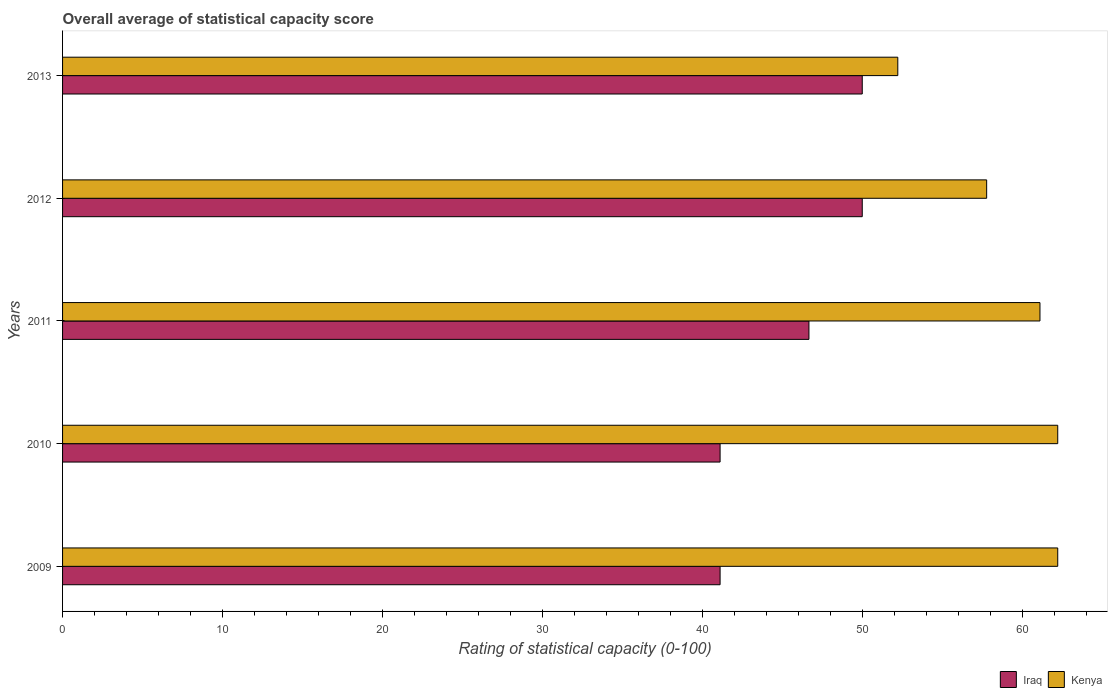How many different coloured bars are there?
Provide a succinct answer. 2. How many bars are there on the 3rd tick from the top?
Your answer should be very brief. 2. How many bars are there on the 5th tick from the bottom?
Provide a succinct answer. 2. What is the rating of statistical capacity in Kenya in 2012?
Offer a very short reply. 57.78. Across all years, what is the maximum rating of statistical capacity in Iraq?
Offer a terse response. 50. Across all years, what is the minimum rating of statistical capacity in Kenya?
Ensure brevity in your answer.  52.22. In which year was the rating of statistical capacity in Iraq maximum?
Provide a succinct answer. 2012. In which year was the rating of statistical capacity in Kenya minimum?
Ensure brevity in your answer.  2013. What is the total rating of statistical capacity in Iraq in the graph?
Provide a short and direct response. 228.89. What is the difference between the rating of statistical capacity in Kenya in 2009 and the rating of statistical capacity in Iraq in 2013?
Your response must be concise. 12.22. What is the average rating of statistical capacity in Iraq per year?
Give a very brief answer. 45.78. In the year 2011, what is the difference between the rating of statistical capacity in Kenya and rating of statistical capacity in Iraq?
Your answer should be compact. 14.44. What is the ratio of the rating of statistical capacity in Kenya in 2009 to that in 2013?
Keep it short and to the point. 1.19. Is the rating of statistical capacity in Iraq in 2012 less than that in 2013?
Ensure brevity in your answer.  No. Is the difference between the rating of statistical capacity in Kenya in 2010 and 2012 greater than the difference between the rating of statistical capacity in Iraq in 2010 and 2012?
Give a very brief answer. Yes. What is the difference between the highest and the lowest rating of statistical capacity in Kenya?
Your response must be concise. 10. What does the 2nd bar from the top in 2013 represents?
Provide a succinct answer. Iraq. What does the 1st bar from the bottom in 2009 represents?
Your answer should be compact. Iraq. Are all the bars in the graph horizontal?
Keep it short and to the point. Yes. What is the difference between two consecutive major ticks on the X-axis?
Make the answer very short. 10. Where does the legend appear in the graph?
Offer a terse response. Bottom right. How many legend labels are there?
Ensure brevity in your answer.  2. What is the title of the graph?
Make the answer very short. Overall average of statistical capacity score. Does "Jordan" appear as one of the legend labels in the graph?
Make the answer very short. No. What is the label or title of the X-axis?
Your answer should be very brief. Rating of statistical capacity (0-100). What is the label or title of the Y-axis?
Make the answer very short. Years. What is the Rating of statistical capacity (0-100) in Iraq in 2009?
Your answer should be compact. 41.11. What is the Rating of statistical capacity (0-100) of Kenya in 2009?
Ensure brevity in your answer.  62.22. What is the Rating of statistical capacity (0-100) in Iraq in 2010?
Offer a terse response. 41.11. What is the Rating of statistical capacity (0-100) of Kenya in 2010?
Your answer should be very brief. 62.22. What is the Rating of statistical capacity (0-100) of Iraq in 2011?
Provide a short and direct response. 46.67. What is the Rating of statistical capacity (0-100) in Kenya in 2011?
Make the answer very short. 61.11. What is the Rating of statistical capacity (0-100) of Iraq in 2012?
Give a very brief answer. 50. What is the Rating of statistical capacity (0-100) of Kenya in 2012?
Your answer should be compact. 57.78. What is the Rating of statistical capacity (0-100) in Iraq in 2013?
Your answer should be compact. 50. What is the Rating of statistical capacity (0-100) of Kenya in 2013?
Give a very brief answer. 52.22. Across all years, what is the maximum Rating of statistical capacity (0-100) in Kenya?
Ensure brevity in your answer.  62.22. Across all years, what is the minimum Rating of statistical capacity (0-100) of Iraq?
Make the answer very short. 41.11. Across all years, what is the minimum Rating of statistical capacity (0-100) in Kenya?
Your response must be concise. 52.22. What is the total Rating of statistical capacity (0-100) of Iraq in the graph?
Offer a terse response. 228.89. What is the total Rating of statistical capacity (0-100) in Kenya in the graph?
Keep it short and to the point. 295.56. What is the difference between the Rating of statistical capacity (0-100) in Iraq in 2009 and that in 2010?
Offer a terse response. 0. What is the difference between the Rating of statistical capacity (0-100) of Kenya in 2009 and that in 2010?
Provide a short and direct response. 0. What is the difference between the Rating of statistical capacity (0-100) in Iraq in 2009 and that in 2011?
Provide a succinct answer. -5.56. What is the difference between the Rating of statistical capacity (0-100) of Kenya in 2009 and that in 2011?
Offer a terse response. 1.11. What is the difference between the Rating of statistical capacity (0-100) of Iraq in 2009 and that in 2012?
Offer a terse response. -8.89. What is the difference between the Rating of statistical capacity (0-100) in Kenya in 2009 and that in 2012?
Keep it short and to the point. 4.44. What is the difference between the Rating of statistical capacity (0-100) in Iraq in 2009 and that in 2013?
Your answer should be compact. -8.89. What is the difference between the Rating of statistical capacity (0-100) of Kenya in 2009 and that in 2013?
Your answer should be very brief. 10. What is the difference between the Rating of statistical capacity (0-100) in Iraq in 2010 and that in 2011?
Keep it short and to the point. -5.56. What is the difference between the Rating of statistical capacity (0-100) of Iraq in 2010 and that in 2012?
Give a very brief answer. -8.89. What is the difference between the Rating of statistical capacity (0-100) in Kenya in 2010 and that in 2012?
Keep it short and to the point. 4.44. What is the difference between the Rating of statistical capacity (0-100) of Iraq in 2010 and that in 2013?
Your answer should be very brief. -8.89. What is the difference between the Rating of statistical capacity (0-100) in Iraq in 2011 and that in 2012?
Provide a short and direct response. -3.33. What is the difference between the Rating of statistical capacity (0-100) in Kenya in 2011 and that in 2012?
Your response must be concise. 3.33. What is the difference between the Rating of statistical capacity (0-100) of Kenya in 2011 and that in 2013?
Make the answer very short. 8.89. What is the difference between the Rating of statistical capacity (0-100) of Iraq in 2012 and that in 2013?
Give a very brief answer. 0. What is the difference between the Rating of statistical capacity (0-100) in Kenya in 2012 and that in 2013?
Your response must be concise. 5.56. What is the difference between the Rating of statistical capacity (0-100) in Iraq in 2009 and the Rating of statistical capacity (0-100) in Kenya in 2010?
Your response must be concise. -21.11. What is the difference between the Rating of statistical capacity (0-100) of Iraq in 2009 and the Rating of statistical capacity (0-100) of Kenya in 2012?
Provide a succinct answer. -16.67. What is the difference between the Rating of statistical capacity (0-100) in Iraq in 2009 and the Rating of statistical capacity (0-100) in Kenya in 2013?
Keep it short and to the point. -11.11. What is the difference between the Rating of statistical capacity (0-100) in Iraq in 2010 and the Rating of statistical capacity (0-100) in Kenya in 2011?
Keep it short and to the point. -20. What is the difference between the Rating of statistical capacity (0-100) in Iraq in 2010 and the Rating of statistical capacity (0-100) in Kenya in 2012?
Give a very brief answer. -16.67. What is the difference between the Rating of statistical capacity (0-100) in Iraq in 2010 and the Rating of statistical capacity (0-100) in Kenya in 2013?
Provide a succinct answer. -11.11. What is the difference between the Rating of statistical capacity (0-100) of Iraq in 2011 and the Rating of statistical capacity (0-100) of Kenya in 2012?
Provide a short and direct response. -11.11. What is the difference between the Rating of statistical capacity (0-100) of Iraq in 2011 and the Rating of statistical capacity (0-100) of Kenya in 2013?
Keep it short and to the point. -5.56. What is the difference between the Rating of statistical capacity (0-100) of Iraq in 2012 and the Rating of statistical capacity (0-100) of Kenya in 2013?
Offer a terse response. -2.22. What is the average Rating of statistical capacity (0-100) in Iraq per year?
Give a very brief answer. 45.78. What is the average Rating of statistical capacity (0-100) of Kenya per year?
Ensure brevity in your answer.  59.11. In the year 2009, what is the difference between the Rating of statistical capacity (0-100) of Iraq and Rating of statistical capacity (0-100) of Kenya?
Offer a terse response. -21.11. In the year 2010, what is the difference between the Rating of statistical capacity (0-100) in Iraq and Rating of statistical capacity (0-100) in Kenya?
Keep it short and to the point. -21.11. In the year 2011, what is the difference between the Rating of statistical capacity (0-100) in Iraq and Rating of statistical capacity (0-100) in Kenya?
Provide a succinct answer. -14.44. In the year 2012, what is the difference between the Rating of statistical capacity (0-100) in Iraq and Rating of statistical capacity (0-100) in Kenya?
Provide a succinct answer. -7.78. In the year 2013, what is the difference between the Rating of statistical capacity (0-100) of Iraq and Rating of statistical capacity (0-100) of Kenya?
Give a very brief answer. -2.22. What is the ratio of the Rating of statistical capacity (0-100) of Iraq in 2009 to that in 2010?
Provide a succinct answer. 1. What is the ratio of the Rating of statistical capacity (0-100) of Kenya in 2009 to that in 2010?
Make the answer very short. 1. What is the ratio of the Rating of statistical capacity (0-100) in Iraq in 2009 to that in 2011?
Offer a terse response. 0.88. What is the ratio of the Rating of statistical capacity (0-100) of Kenya in 2009 to that in 2011?
Offer a terse response. 1.02. What is the ratio of the Rating of statistical capacity (0-100) in Iraq in 2009 to that in 2012?
Ensure brevity in your answer.  0.82. What is the ratio of the Rating of statistical capacity (0-100) of Kenya in 2009 to that in 2012?
Offer a very short reply. 1.08. What is the ratio of the Rating of statistical capacity (0-100) in Iraq in 2009 to that in 2013?
Your answer should be very brief. 0.82. What is the ratio of the Rating of statistical capacity (0-100) of Kenya in 2009 to that in 2013?
Give a very brief answer. 1.19. What is the ratio of the Rating of statistical capacity (0-100) of Iraq in 2010 to that in 2011?
Ensure brevity in your answer.  0.88. What is the ratio of the Rating of statistical capacity (0-100) of Kenya in 2010 to that in 2011?
Ensure brevity in your answer.  1.02. What is the ratio of the Rating of statistical capacity (0-100) in Iraq in 2010 to that in 2012?
Ensure brevity in your answer.  0.82. What is the ratio of the Rating of statistical capacity (0-100) of Iraq in 2010 to that in 2013?
Make the answer very short. 0.82. What is the ratio of the Rating of statistical capacity (0-100) of Kenya in 2010 to that in 2013?
Keep it short and to the point. 1.19. What is the ratio of the Rating of statistical capacity (0-100) of Iraq in 2011 to that in 2012?
Your answer should be very brief. 0.93. What is the ratio of the Rating of statistical capacity (0-100) of Kenya in 2011 to that in 2012?
Give a very brief answer. 1.06. What is the ratio of the Rating of statistical capacity (0-100) of Kenya in 2011 to that in 2013?
Provide a succinct answer. 1.17. What is the ratio of the Rating of statistical capacity (0-100) in Kenya in 2012 to that in 2013?
Your answer should be very brief. 1.11. What is the difference between the highest and the second highest Rating of statistical capacity (0-100) of Kenya?
Keep it short and to the point. 0. What is the difference between the highest and the lowest Rating of statistical capacity (0-100) of Iraq?
Offer a very short reply. 8.89. 